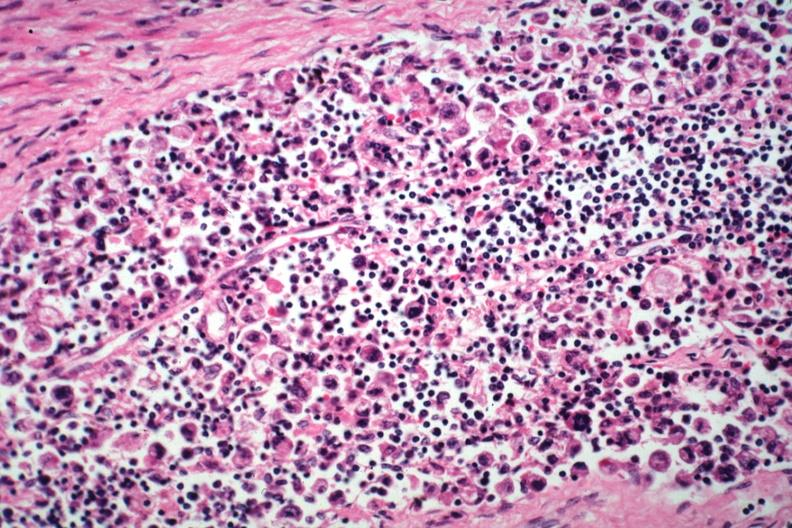s lymph node present?
Answer the question using a single word or phrase. Yes 